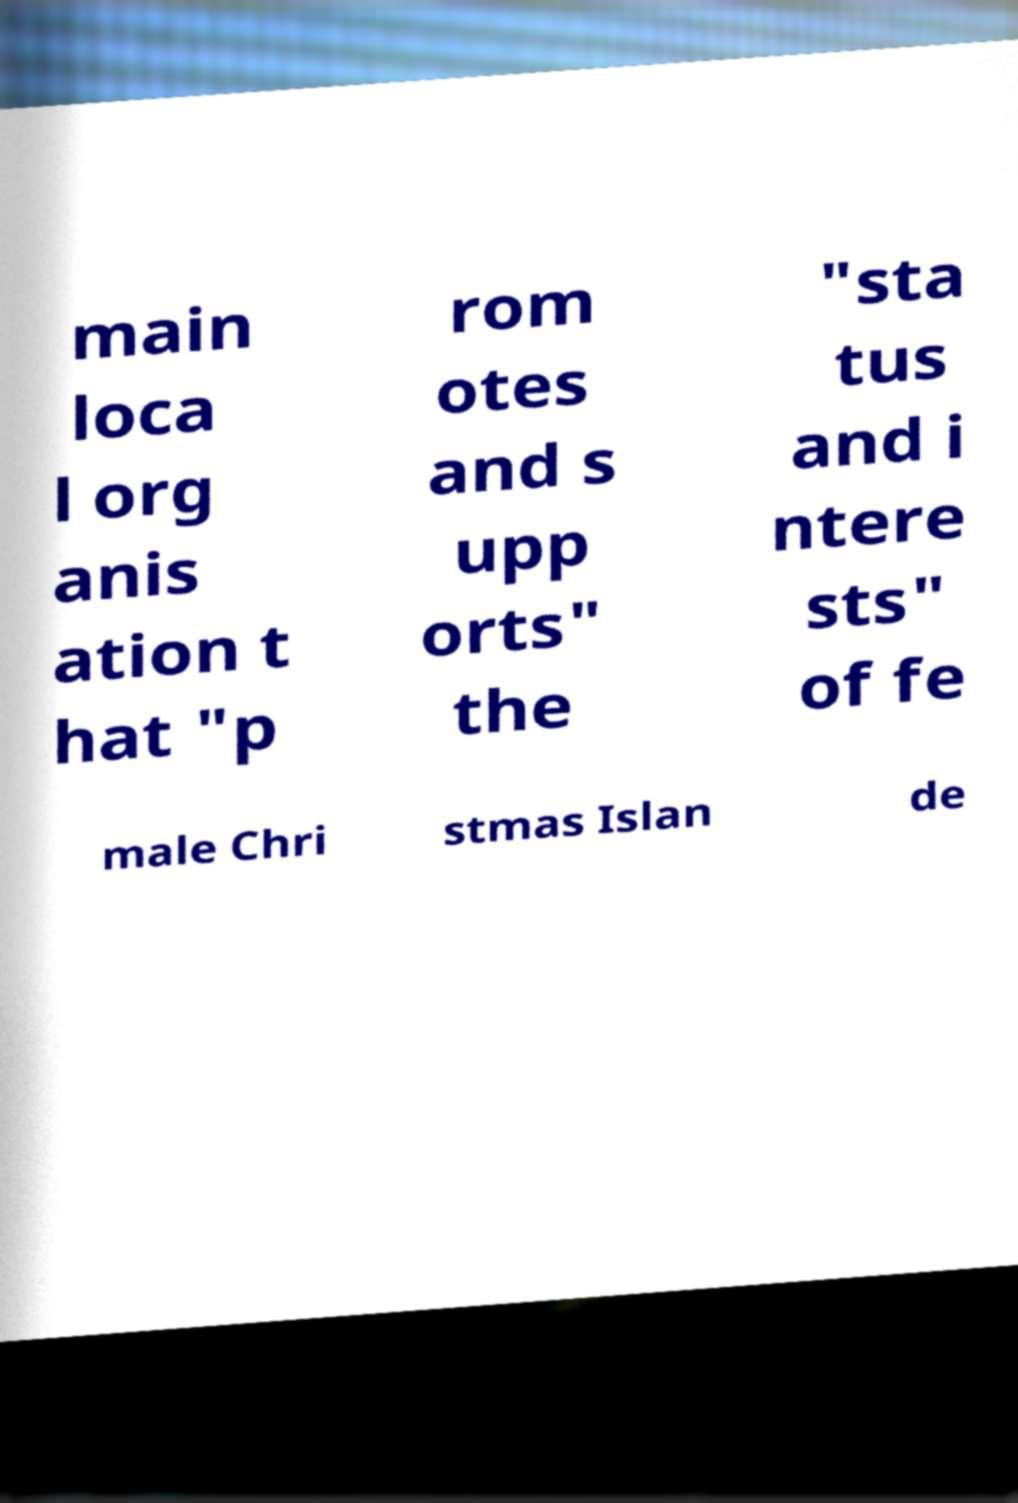What messages or text are displayed in this image? I need them in a readable, typed format. main loca l org anis ation t hat "p rom otes and s upp orts" the "sta tus and i ntere sts" of fe male Chri stmas Islan de 